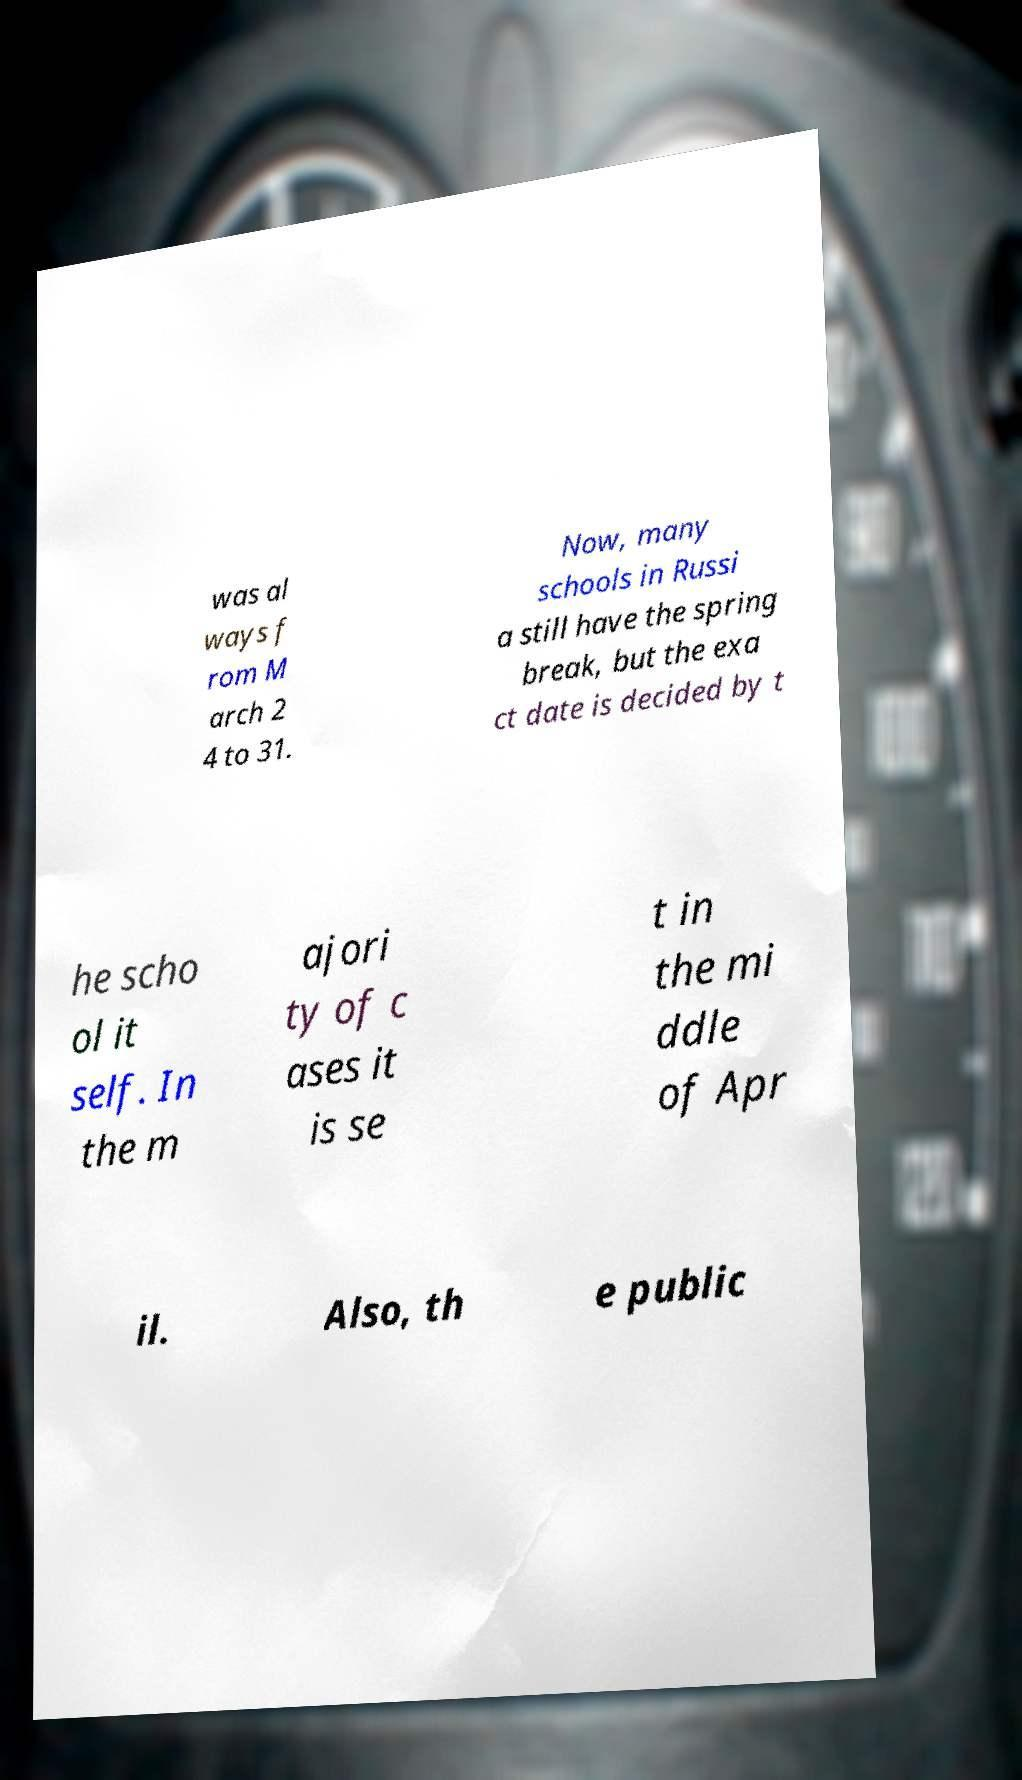For documentation purposes, I need the text within this image transcribed. Could you provide that? was al ways f rom M arch 2 4 to 31. Now, many schools in Russi a still have the spring break, but the exa ct date is decided by t he scho ol it self. In the m ajori ty of c ases it is se t in the mi ddle of Apr il. Also, th e public 